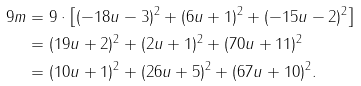Convert formula to latex. <formula><loc_0><loc_0><loc_500><loc_500>9 m & = 9 \cdot \left [ ( - 1 8 u - 3 ) ^ { 2 } + ( 6 u + 1 ) ^ { 2 } + ( - 1 5 u - 2 ) ^ { 2 } \right ] \\ & = ( 1 9 u + 2 ) ^ { 2 } + ( 2 u + 1 ) ^ { 2 } + ( 7 0 u + 1 1 ) ^ { 2 } \\ & = ( 1 0 u + 1 ) ^ { 2 } + ( 2 6 u + 5 ) ^ { 2 } + ( 6 7 u + 1 0 ) ^ { 2 } .</formula> 